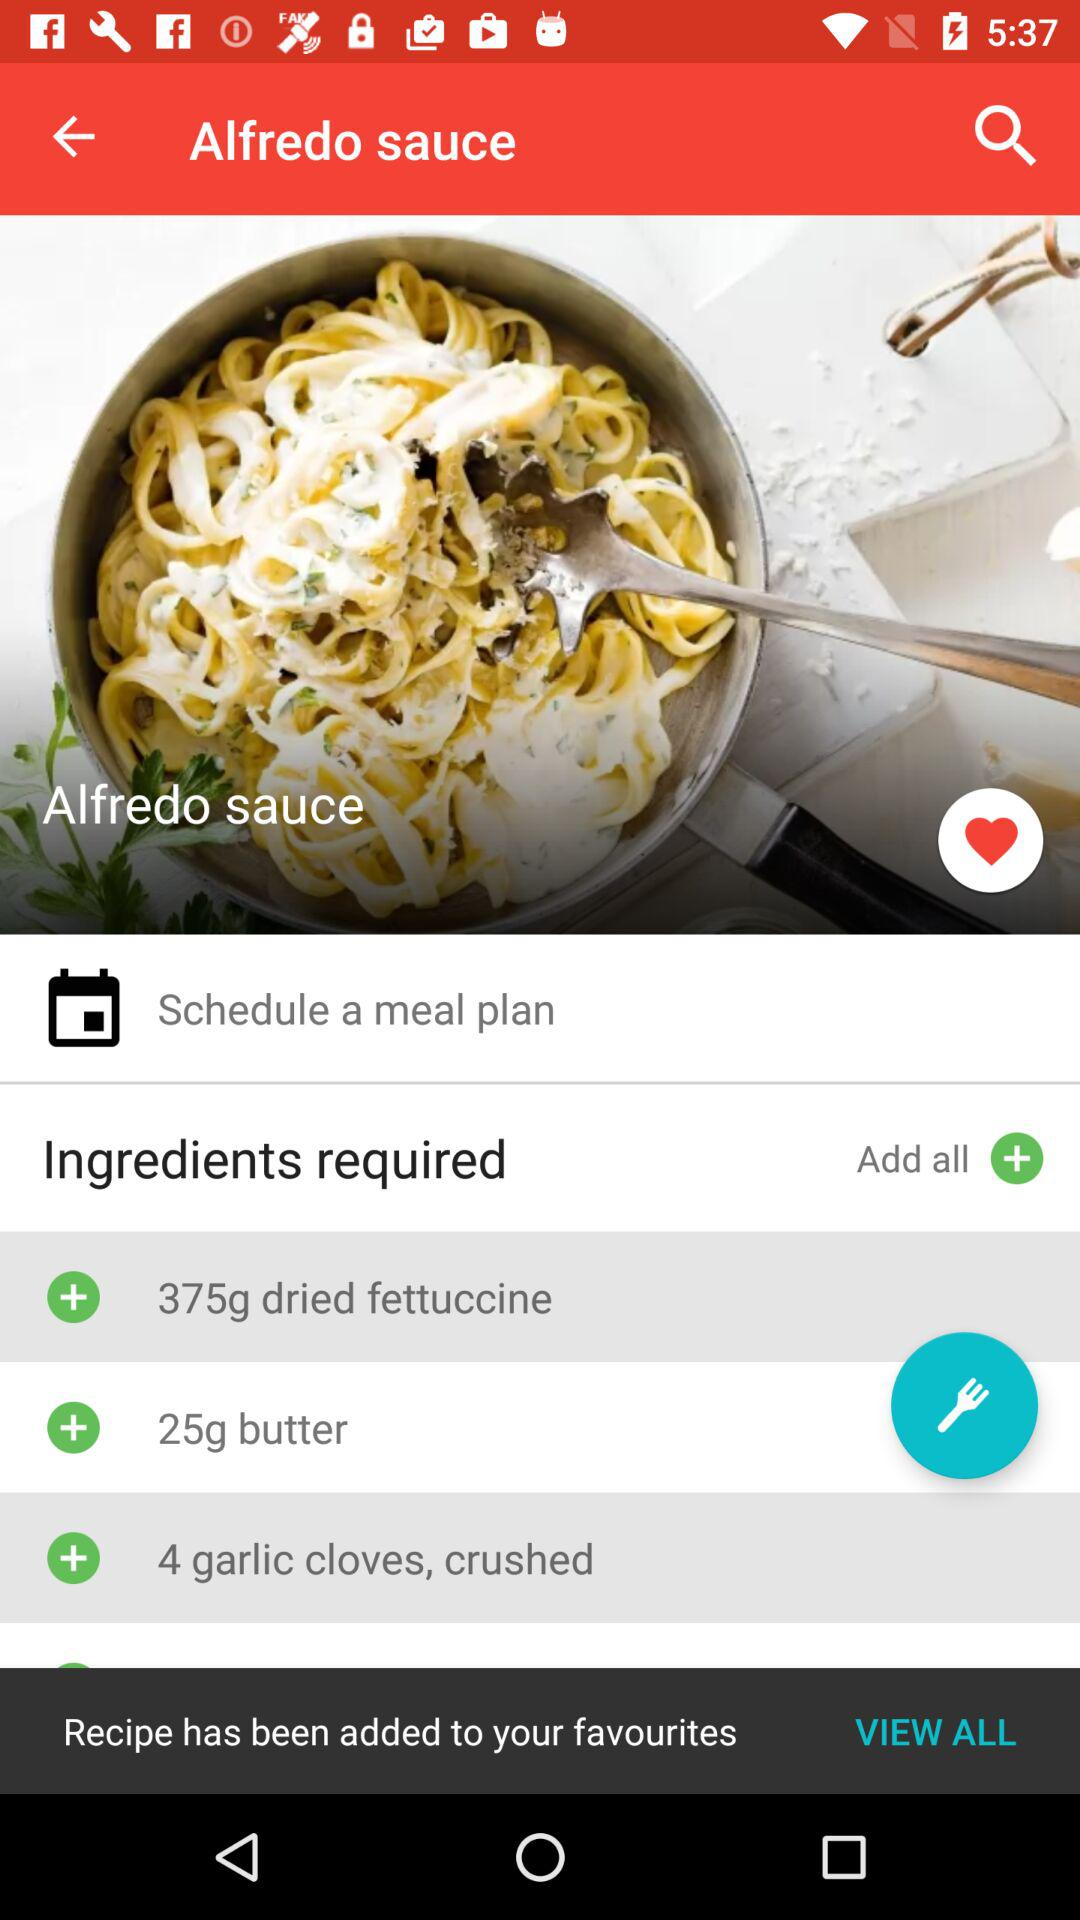How much butter is required? The butter required is 25g. 